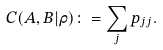Convert formula to latex. <formula><loc_0><loc_0><loc_500><loc_500>C ( A , B | \rho ) \colon = \sum _ { j } p _ { j j } .</formula> 